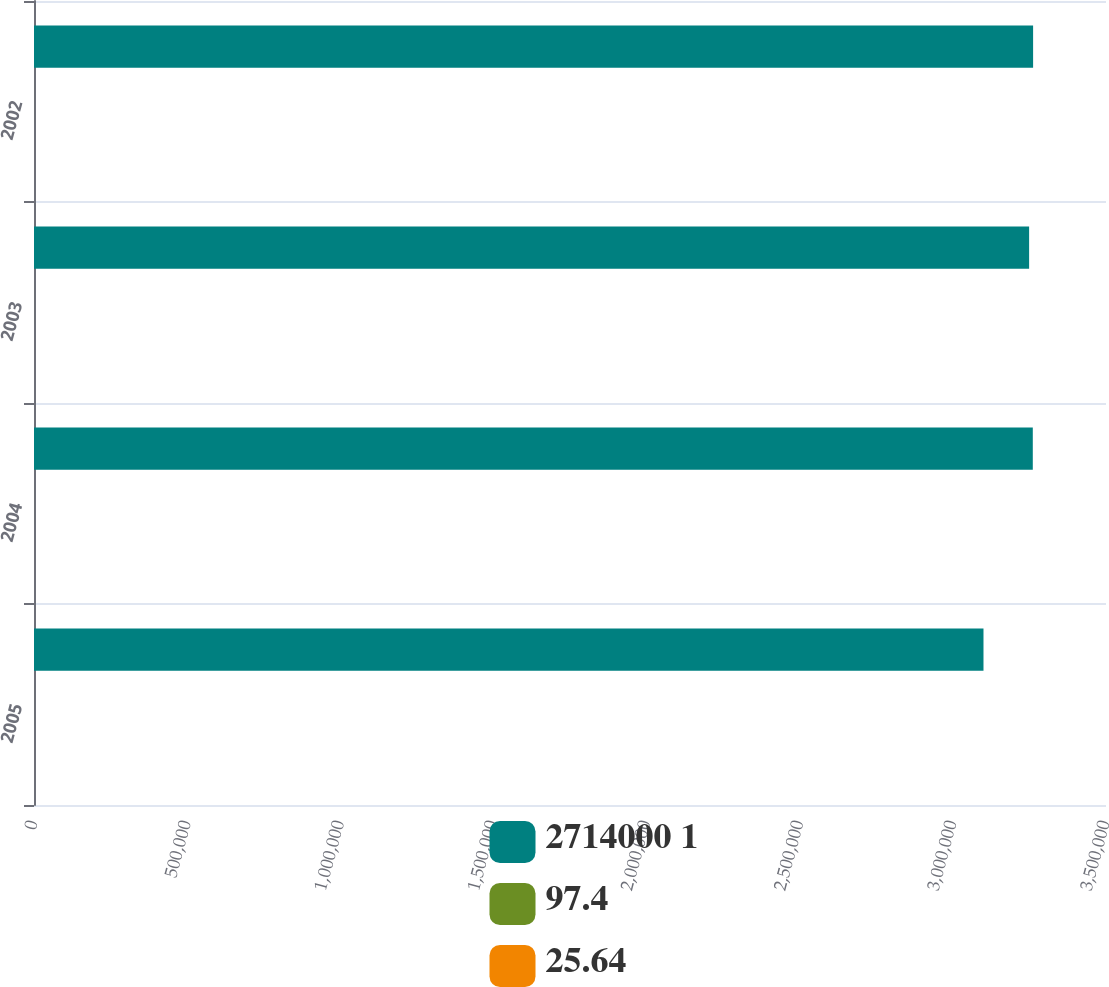Convert chart. <chart><loc_0><loc_0><loc_500><loc_500><stacked_bar_chart><ecel><fcel>2005<fcel>2004<fcel>2003<fcel>2002<nl><fcel>2714000 1<fcel>3.1e+06<fcel>3.261e+06<fcel>3.249e+06<fcel>3.262e+06<nl><fcel>97.4<fcel>97<fcel>96.5<fcel>93.6<fcel>92.8<nl><fcel>25.64<fcel>26.42<fcel>27.59<fcel>27.73<fcel>26.32<nl></chart> 